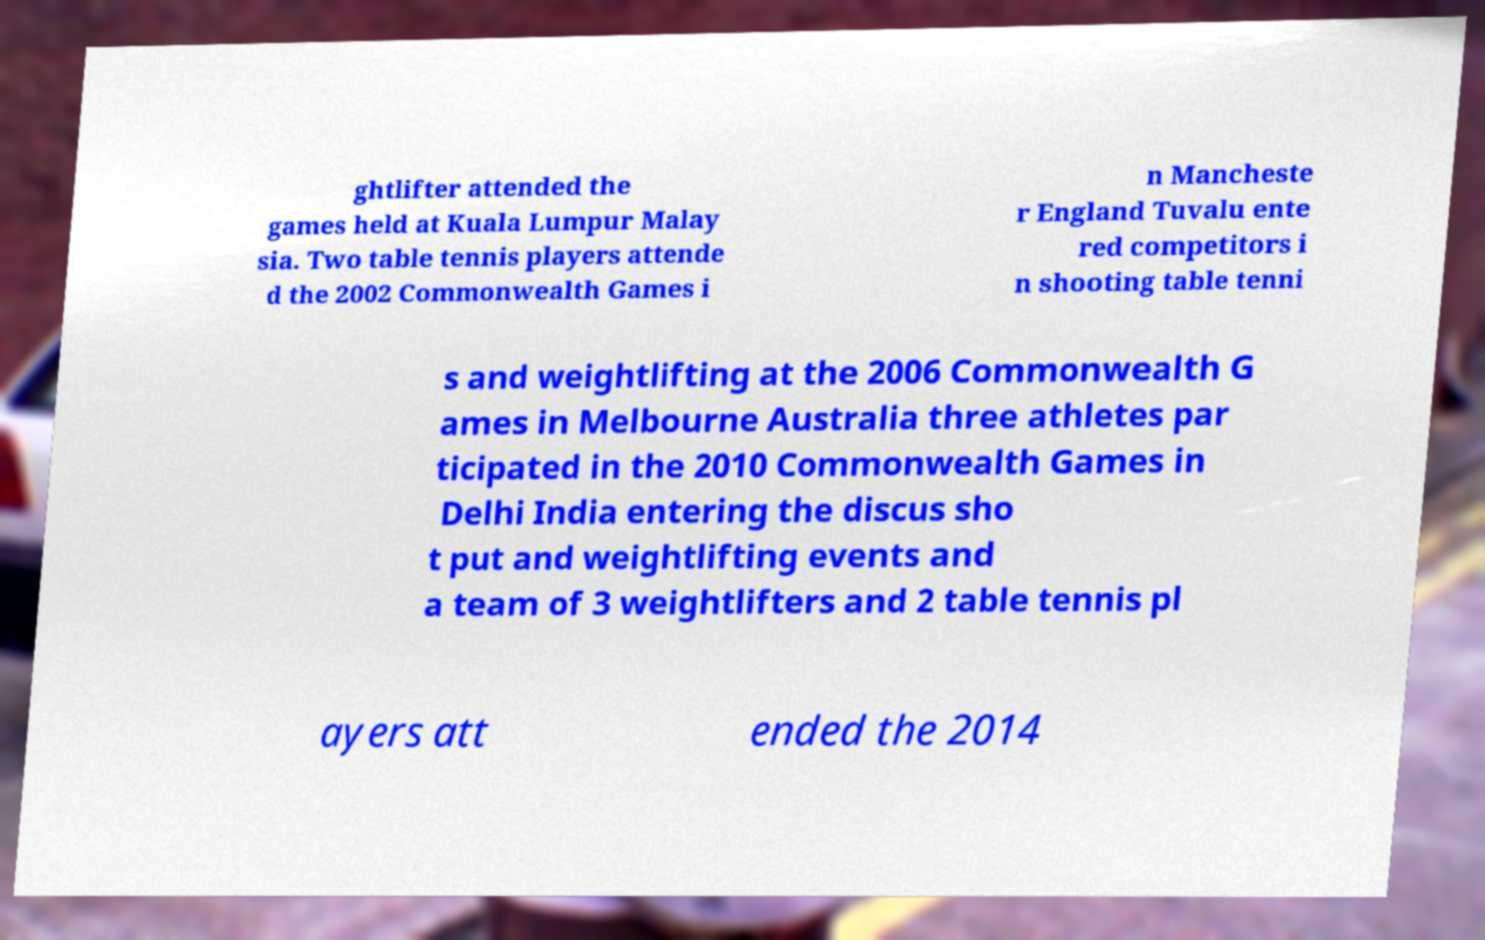Please identify and transcribe the text found in this image. ghtlifter attended the games held at Kuala Lumpur Malay sia. Two table tennis players attende d the 2002 Commonwealth Games i n Mancheste r England Tuvalu ente red competitors i n shooting table tenni s and weightlifting at the 2006 Commonwealth G ames in Melbourne Australia three athletes par ticipated in the 2010 Commonwealth Games in Delhi India entering the discus sho t put and weightlifting events and a team of 3 weightlifters and 2 table tennis pl ayers att ended the 2014 